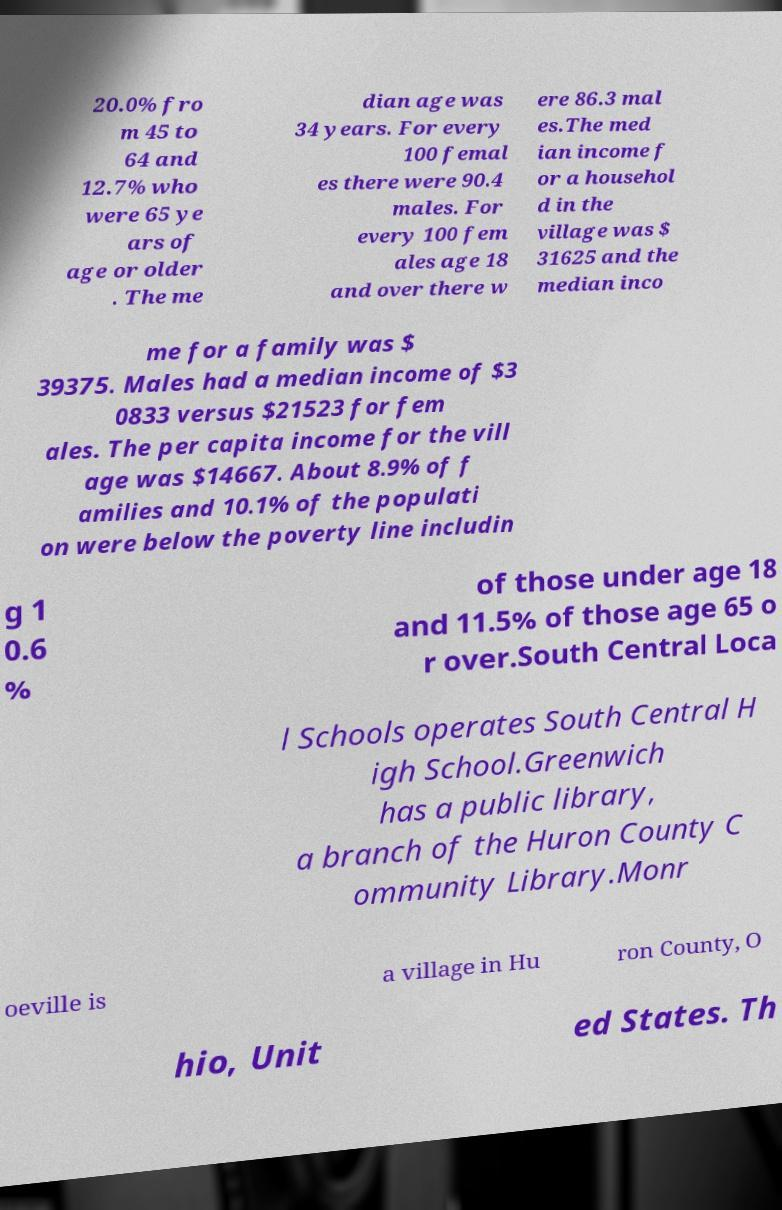Can you read and provide the text displayed in the image?This photo seems to have some interesting text. Can you extract and type it out for me? 20.0% fro m 45 to 64 and 12.7% who were 65 ye ars of age or older . The me dian age was 34 years. For every 100 femal es there were 90.4 males. For every 100 fem ales age 18 and over there w ere 86.3 mal es.The med ian income f or a househol d in the village was $ 31625 and the median inco me for a family was $ 39375. Males had a median income of $3 0833 versus $21523 for fem ales. The per capita income for the vill age was $14667. About 8.9% of f amilies and 10.1% of the populati on were below the poverty line includin g 1 0.6 % of those under age 18 and 11.5% of those age 65 o r over.South Central Loca l Schools operates South Central H igh School.Greenwich has a public library, a branch of the Huron County C ommunity Library.Monr oeville is a village in Hu ron County, O hio, Unit ed States. Th 